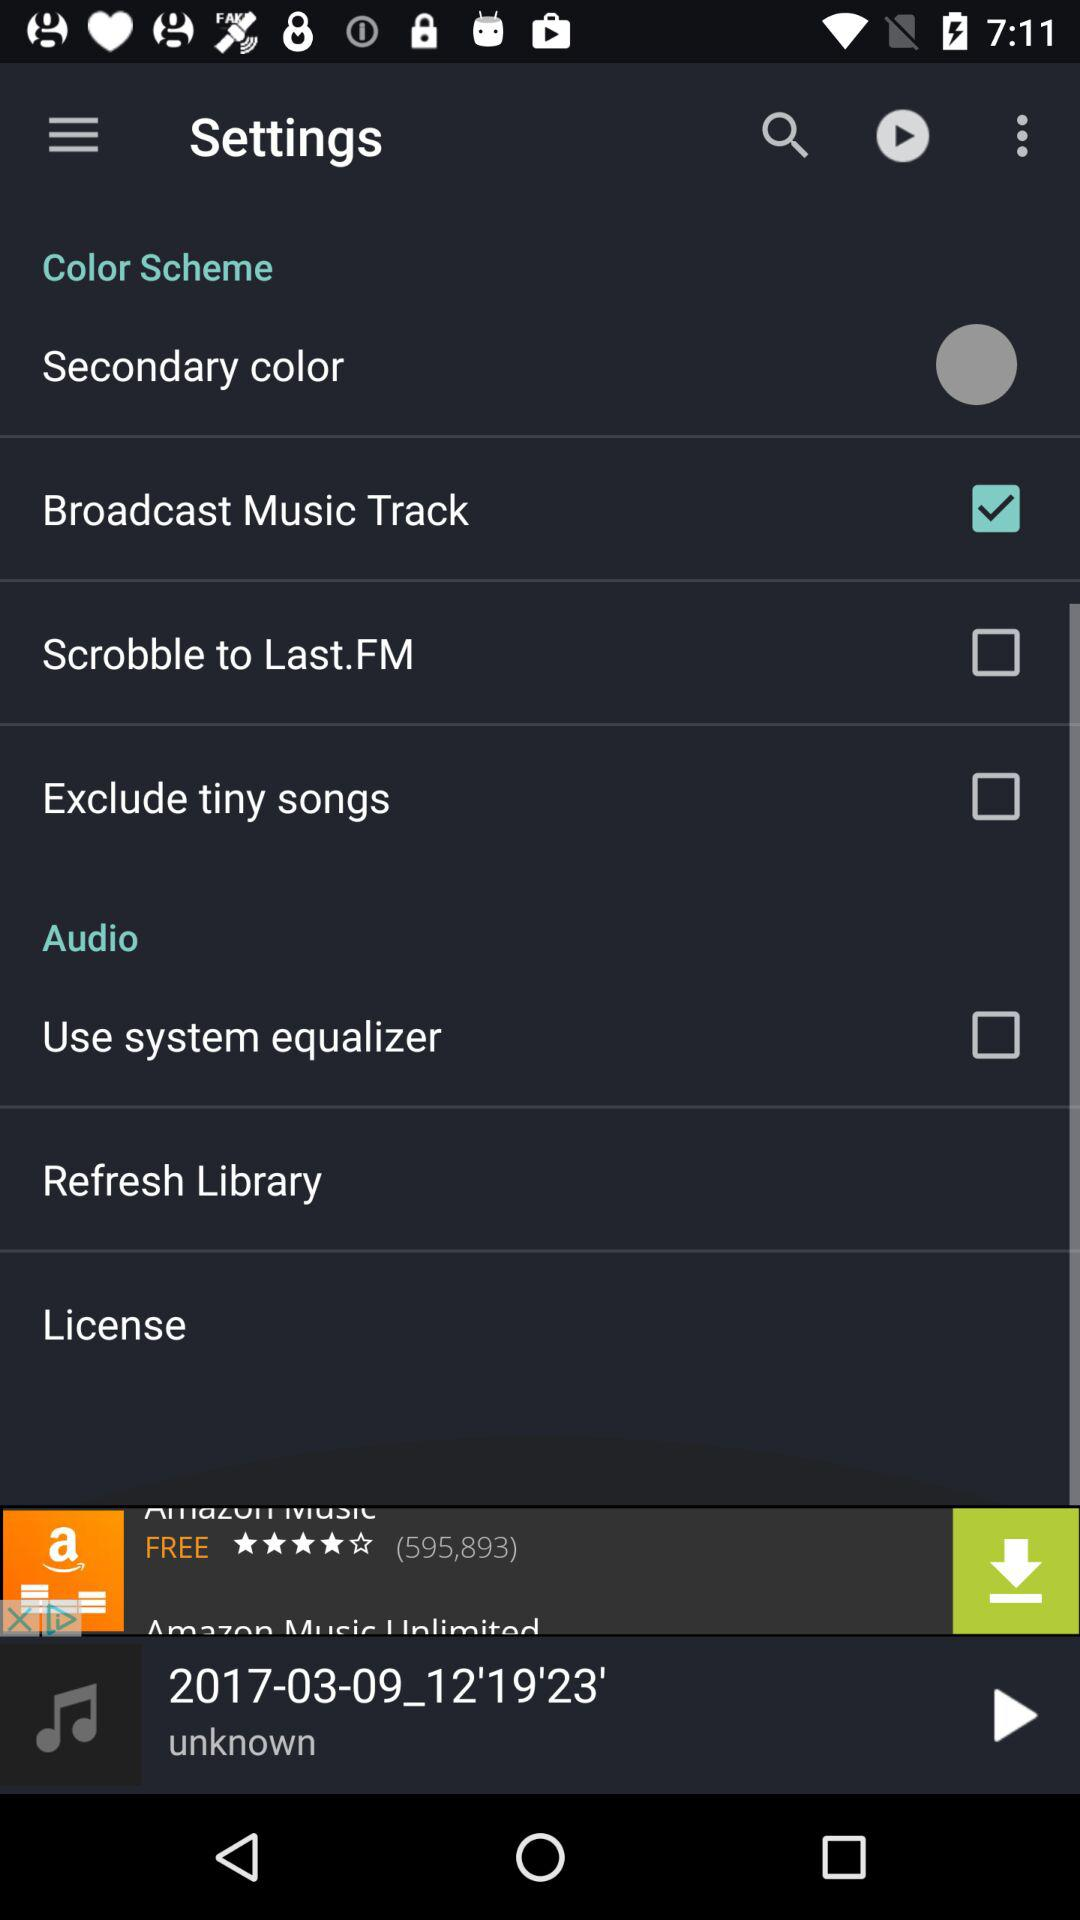Which is the selected checkbox? The selected checkbox is "Broadcast Music Track". 